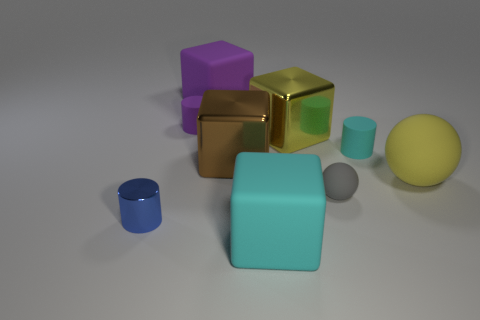Is the block that is in front of the yellow matte ball made of the same material as the cylinder in front of the small sphere?
Make the answer very short. No. What material is the block in front of the big rubber ball?
Provide a succinct answer. Rubber. There is a big matte object in front of the small metal object; is its shape the same as the yellow thing left of the gray matte object?
Offer a very short reply. Yes. Are there any small metal blocks?
Your answer should be very brief. No. There is a purple object that is the same shape as the big brown metallic thing; what is it made of?
Your answer should be very brief. Rubber. There is a brown shiny thing; are there any small matte things in front of it?
Your response must be concise. Yes. Is the gray thing that is right of the brown metallic block made of the same material as the blue thing?
Your answer should be compact. No. Is there a metallic thing of the same color as the large ball?
Your answer should be compact. Yes. What is the shape of the yellow rubber thing?
Make the answer very short. Sphere. There is a big rubber block that is behind the tiny matte cylinder that is to the left of the brown shiny block; what color is it?
Your answer should be very brief. Purple. 